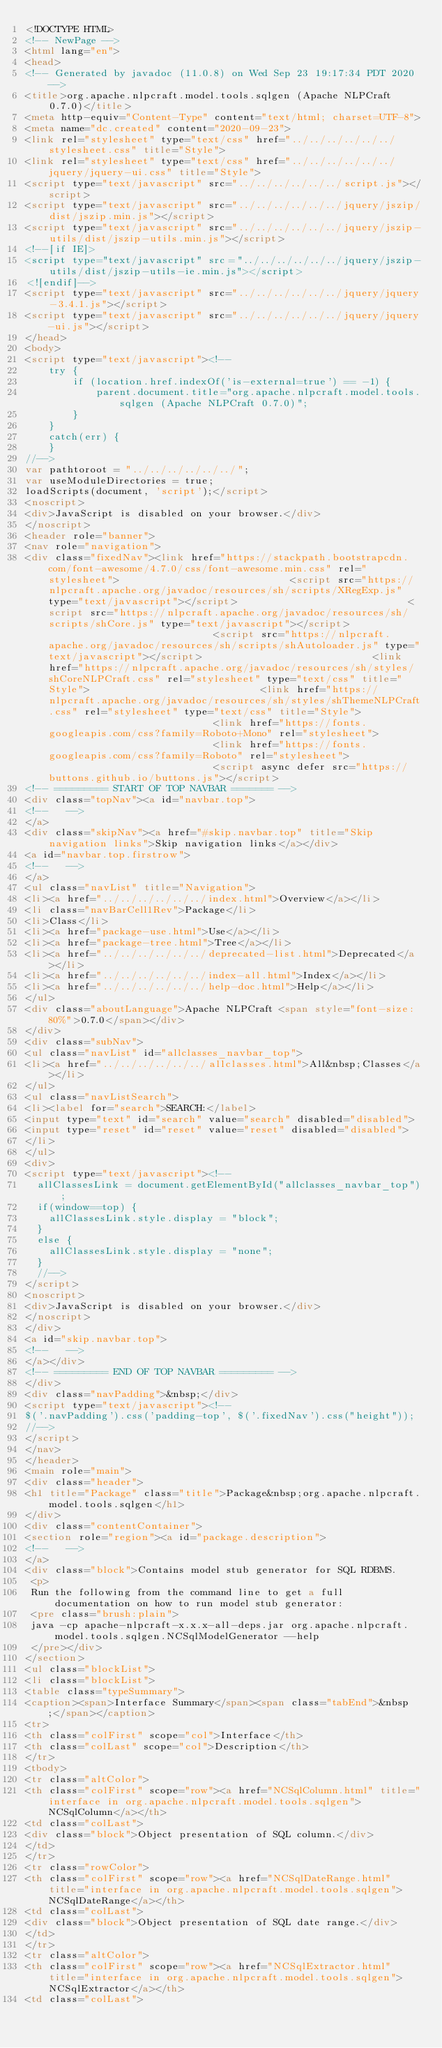Convert code to text. <code><loc_0><loc_0><loc_500><loc_500><_HTML_><!DOCTYPE HTML>
<!-- NewPage -->
<html lang="en">
<head>
<!-- Generated by javadoc (11.0.8) on Wed Sep 23 19:17:34 PDT 2020 -->
<title>org.apache.nlpcraft.model.tools.sqlgen (Apache NLPCraft 0.7.0)</title>
<meta http-equiv="Content-Type" content="text/html; charset=UTF-8">
<meta name="dc.created" content="2020-09-23">
<link rel="stylesheet" type="text/css" href="../../../../../../stylesheet.css" title="Style">
<link rel="stylesheet" type="text/css" href="../../../../../../jquery/jquery-ui.css" title="Style">
<script type="text/javascript" src="../../../../../../script.js"></script>
<script type="text/javascript" src="../../../../../../jquery/jszip/dist/jszip.min.js"></script>
<script type="text/javascript" src="../../../../../../jquery/jszip-utils/dist/jszip-utils.min.js"></script>
<!--[if IE]>
<script type="text/javascript" src="../../../../../../jquery/jszip-utils/dist/jszip-utils-ie.min.js"></script>
<![endif]-->
<script type="text/javascript" src="../../../../../../jquery/jquery-3.4.1.js"></script>
<script type="text/javascript" src="../../../../../../jquery/jquery-ui.js"></script>
</head>
<body>
<script type="text/javascript"><!--
    try {
        if (location.href.indexOf('is-external=true') == -1) {
            parent.document.title="org.apache.nlpcraft.model.tools.sqlgen (Apache NLPCraft 0.7.0)";
        }
    }
    catch(err) {
    }
//-->
var pathtoroot = "../../../../../../";
var useModuleDirectories = true;
loadScripts(document, 'script');</script>
<noscript>
<div>JavaScript is disabled on your browser.</div>
</noscript>
<header role="banner">
<nav role="navigation">
<div class="fixedNav"><link href="https://stackpath.bootstrapcdn.com/font-awesome/4.7.0/css/font-awesome.min.css" rel="stylesheet">                             <script src="https://nlpcraft.apache.org/javadoc/resources/sh/scripts/XRegExp.js" type="text/javascript"></script>                             <script src="https://nlpcraft.apache.org/javadoc/resources/sh/scripts/shCore.js" type="text/javascript"></script>                             <script src="https://nlpcraft.apache.org/javadoc/resources/sh/scripts/shAutoloader.js" type="text/javascript"></script>                             <link href="https://nlpcraft.apache.org/javadoc/resources/sh/styles/shCoreNLPCraft.css" rel="stylesheet" type="text/css" title="Style">                             <link href="https://nlpcraft.apache.org/javadoc/resources/sh/styles/shThemeNLPCraft.css" rel="stylesheet" type="text/css" title="Style">                             <link href="https://fonts.googleapis.com/css?family=Roboto+Mono" rel="stylesheet">                             <link href="https://fonts.googleapis.com/css?family=Roboto" rel="stylesheet">                             <script async defer src="https://buttons.github.io/buttons.js"></script>
<!-- ========= START OF TOP NAVBAR ======= -->
<div class="topNav"><a id="navbar.top">
<!--   -->
</a>
<div class="skipNav"><a href="#skip.navbar.top" title="Skip navigation links">Skip navigation links</a></div>
<a id="navbar.top.firstrow">
<!--   -->
</a>
<ul class="navList" title="Navigation">
<li><a href="../../../../../../index.html">Overview</a></li>
<li class="navBarCell1Rev">Package</li>
<li>Class</li>
<li><a href="package-use.html">Use</a></li>
<li><a href="package-tree.html">Tree</a></li>
<li><a href="../../../../../../deprecated-list.html">Deprecated</a></li>
<li><a href="../../../../../../index-all.html">Index</a></li>
<li><a href="../../../../../../help-doc.html">Help</a></li>
</ul>
<div class="aboutLanguage">Apache NLPCraft <span style="font-size: 80%">0.7.0</span></div>
</div>
<div class="subNav">
<ul class="navList" id="allclasses_navbar_top">
<li><a href="../../../../../../allclasses.html">All&nbsp;Classes</a></li>
</ul>
<ul class="navListSearch">
<li><label for="search">SEARCH:</label>
<input type="text" id="search" value="search" disabled="disabled">
<input type="reset" id="reset" value="reset" disabled="disabled">
</li>
</ul>
<div>
<script type="text/javascript"><!--
  allClassesLink = document.getElementById("allclasses_navbar_top");
  if(window==top) {
    allClassesLink.style.display = "block";
  }
  else {
    allClassesLink.style.display = "none";
  }
  //-->
</script>
<noscript>
<div>JavaScript is disabled on your browser.</div>
</noscript>
</div>
<a id="skip.navbar.top">
<!--   -->
</a></div>
<!-- ========= END OF TOP NAVBAR ========= -->
</div>
<div class="navPadding">&nbsp;</div>
<script type="text/javascript"><!--
$('.navPadding').css('padding-top', $('.fixedNav').css("height"));
//-->
</script>
</nav>
</header>
<main role="main">
<div class="header">
<h1 title="Package" class="title">Package&nbsp;org.apache.nlpcraft.model.tools.sqlgen</h1>
</div>
<div class="contentContainer">
<section role="region"><a id="package.description">
<!--   -->
</a>
<div class="block">Contains model stub generator for SQL RDBMS.
 <p>
 Run the following from the command line to get a full documentation on how to run model stub generator:
 <pre class="brush:plain">
 java -cp apache-nlpcraft-x.x.x-all-deps.jar org.apache.nlpcraft.model.tools.sqlgen.NCSqlModelGenerator --help
 </pre></div>
</section>
<ul class="blockList">
<li class="blockList">
<table class="typeSummary">
<caption><span>Interface Summary</span><span class="tabEnd">&nbsp;</span></caption>
<tr>
<th class="colFirst" scope="col">Interface</th>
<th class="colLast" scope="col">Description</th>
</tr>
<tbody>
<tr class="altColor">
<th class="colFirst" scope="row"><a href="NCSqlColumn.html" title="interface in org.apache.nlpcraft.model.tools.sqlgen">NCSqlColumn</a></th>
<td class="colLast">
<div class="block">Object presentation of SQL column.</div>
</td>
</tr>
<tr class="rowColor">
<th class="colFirst" scope="row"><a href="NCSqlDateRange.html" title="interface in org.apache.nlpcraft.model.tools.sqlgen">NCSqlDateRange</a></th>
<td class="colLast">
<div class="block">Object presentation of SQL date range.</div>
</td>
</tr>
<tr class="altColor">
<th class="colFirst" scope="row"><a href="NCSqlExtractor.html" title="interface in org.apache.nlpcraft.model.tools.sqlgen">NCSqlExtractor</a></th>
<td class="colLast"></code> 